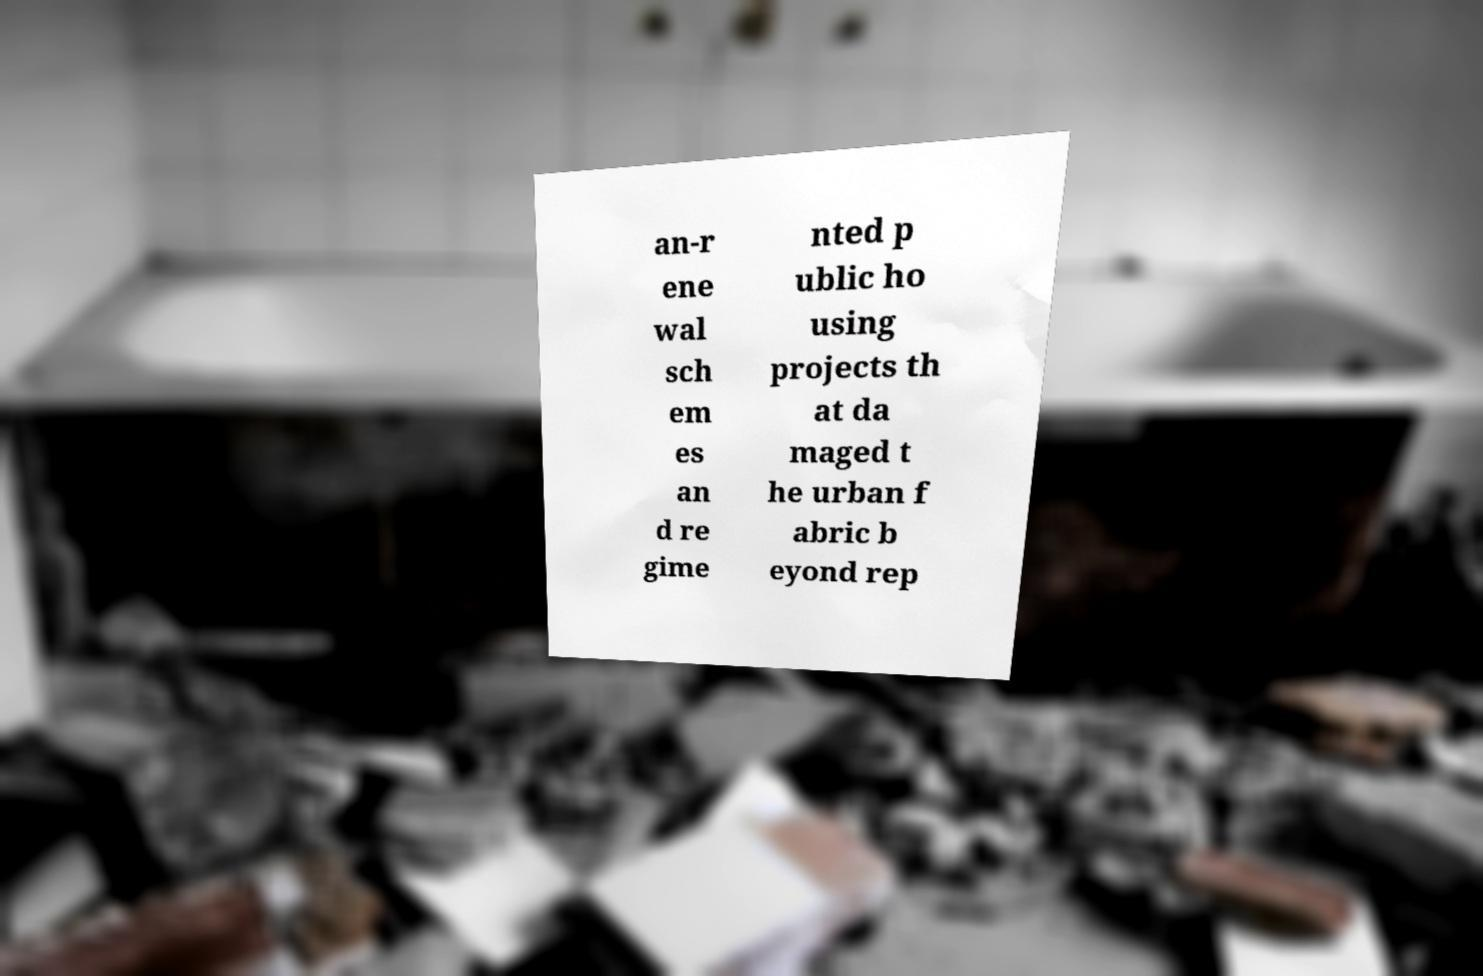Please read and relay the text visible in this image. What does it say? an-r ene wal sch em es an d re gime nted p ublic ho using projects th at da maged t he urban f abric b eyond rep 